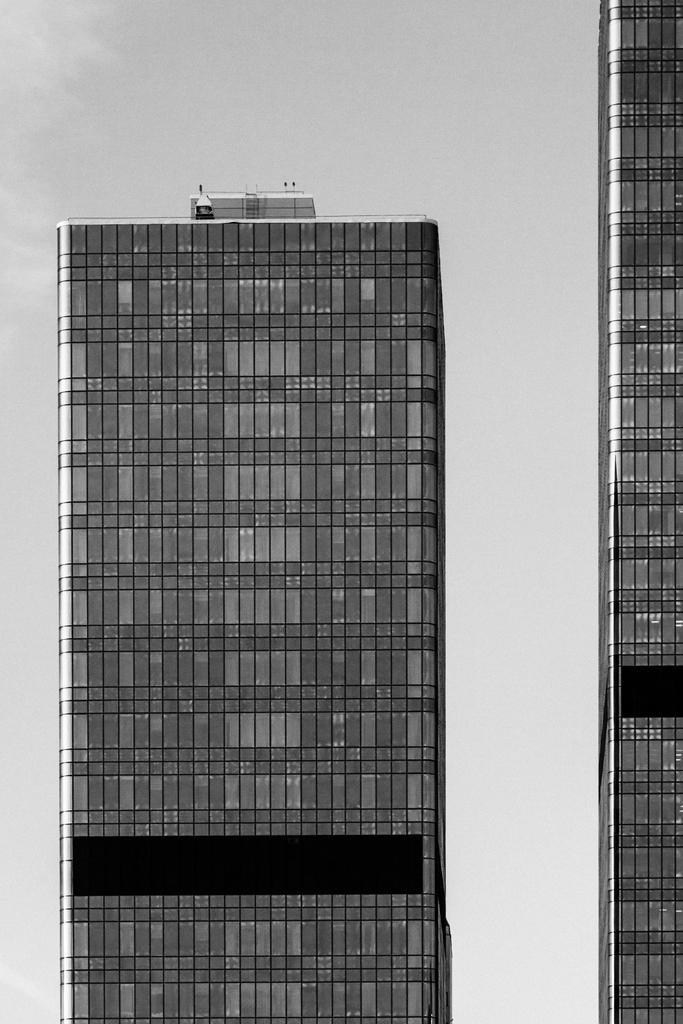Describe this image in one or two sentences. This is a black and white image. In this image we can see two buildings. 